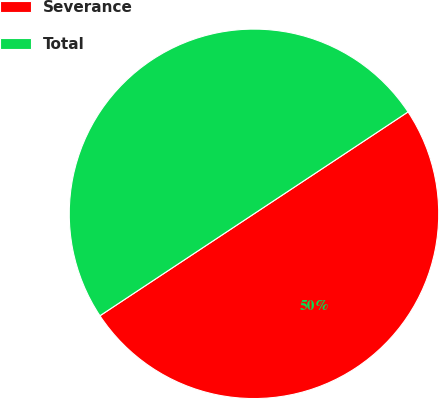Convert chart. <chart><loc_0><loc_0><loc_500><loc_500><pie_chart><fcel>Severance<fcel>Total<nl><fcel>50.0%<fcel>50.0%<nl></chart> 